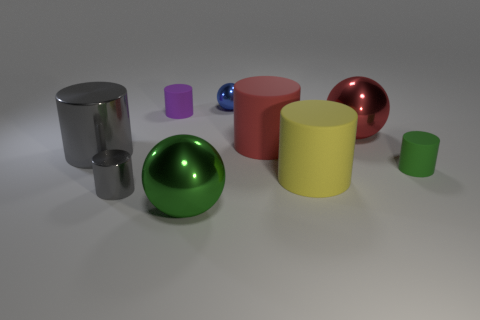Subtract all purple cylinders. How many cylinders are left? 5 Subtract all large metal cylinders. How many cylinders are left? 5 Subtract all brown cylinders. Subtract all red balls. How many cylinders are left? 6 Subtract all balls. How many objects are left? 6 Subtract all big matte cylinders. Subtract all large green metal objects. How many objects are left? 6 Add 6 large red metal objects. How many large red metal objects are left? 7 Add 2 purple cylinders. How many purple cylinders exist? 3 Subtract 0 gray cubes. How many objects are left? 9 